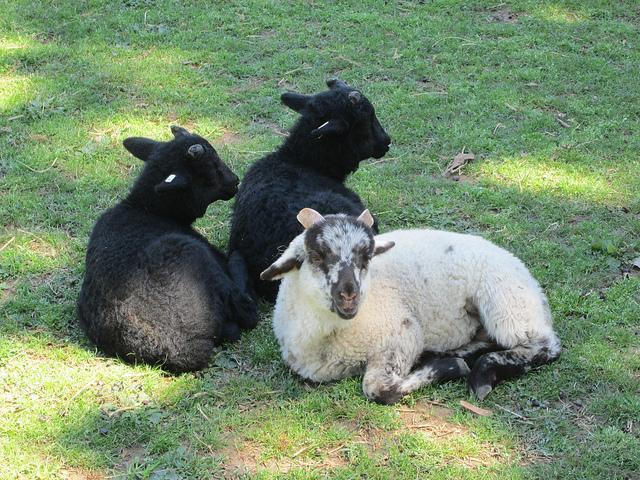How many sheep can you see?
Give a very brief answer. 3. How many people are wearing sunglasses in this photo?
Give a very brief answer. 0. 